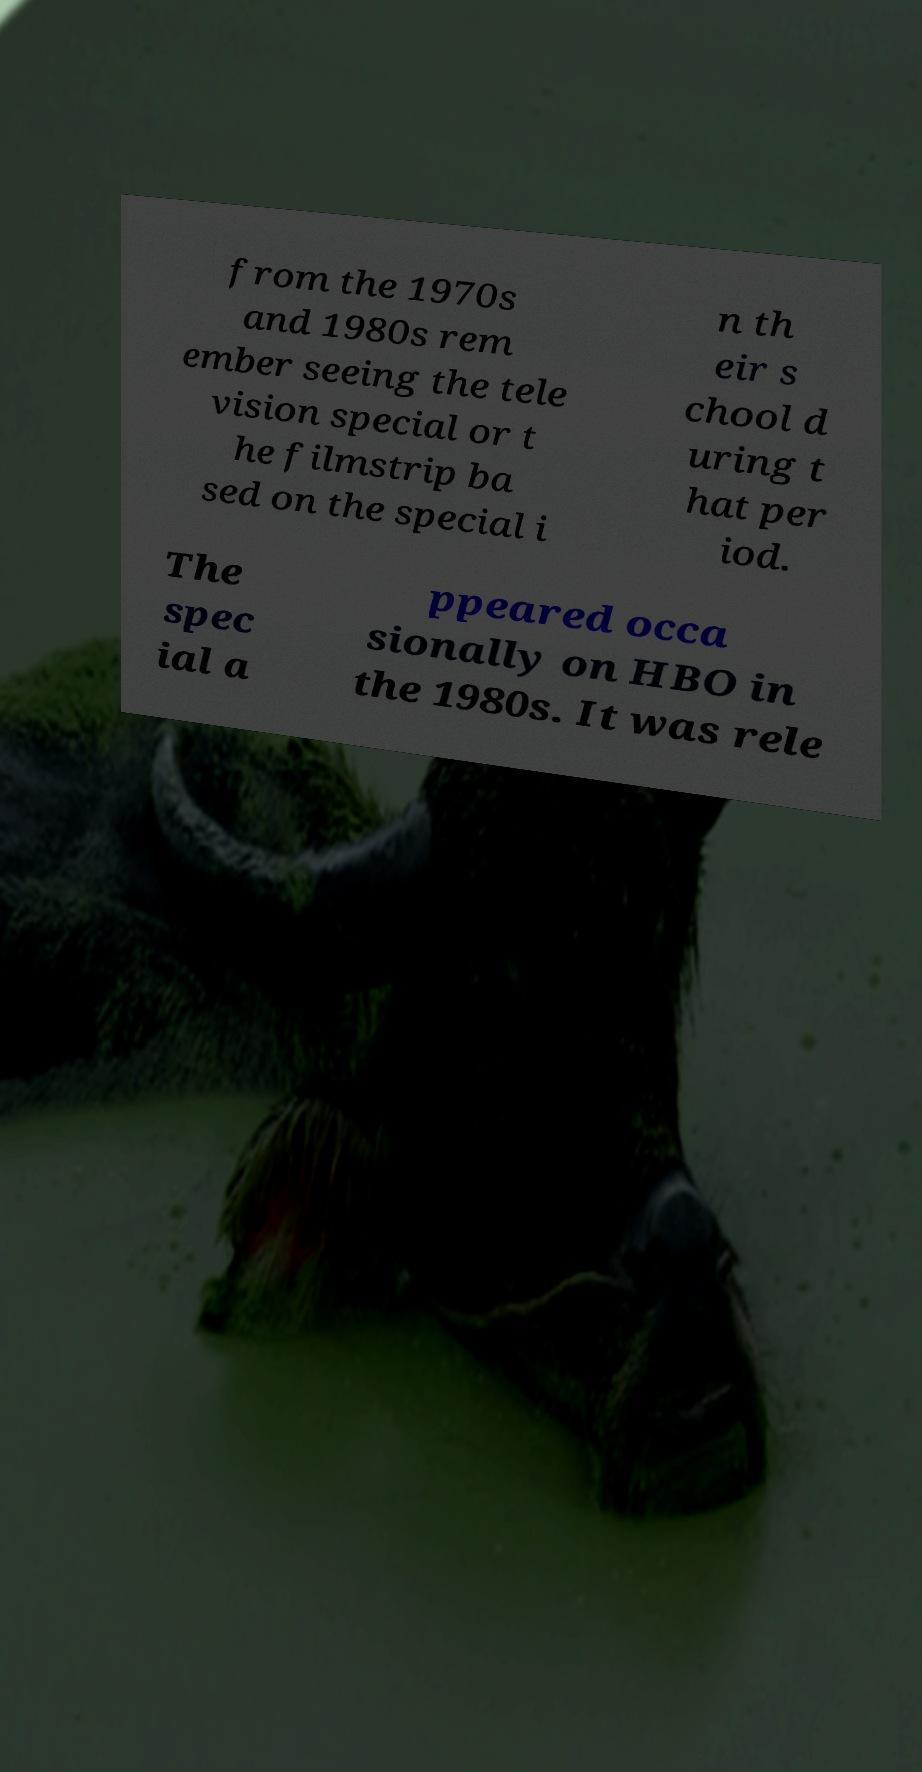Could you extract and type out the text from this image? from the 1970s and 1980s rem ember seeing the tele vision special or t he filmstrip ba sed on the special i n th eir s chool d uring t hat per iod. The spec ial a ppeared occa sionally on HBO in the 1980s. It was rele 